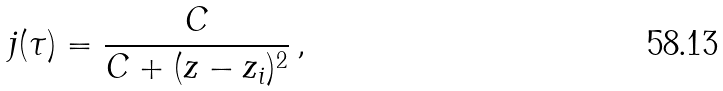<formula> <loc_0><loc_0><loc_500><loc_500>j ( \tau ) = \frac { C } { C + ( z - z _ { i } ) ^ { 2 } } \, ,</formula> 